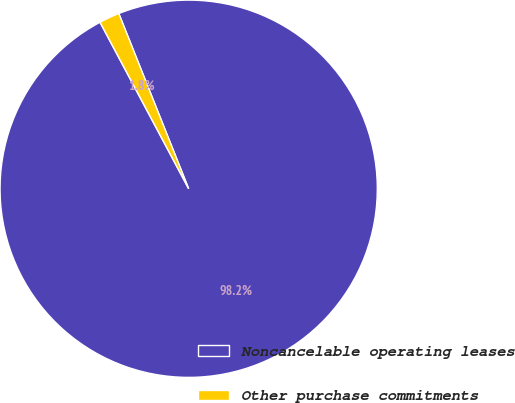Convert chart to OTSL. <chart><loc_0><loc_0><loc_500><loc_500><pie_chart><fcel>Noncancelable operating leases<fcel>Other purchase commitments<nl><fcel>98.25%<fcel>1.75%<nl></chart> 